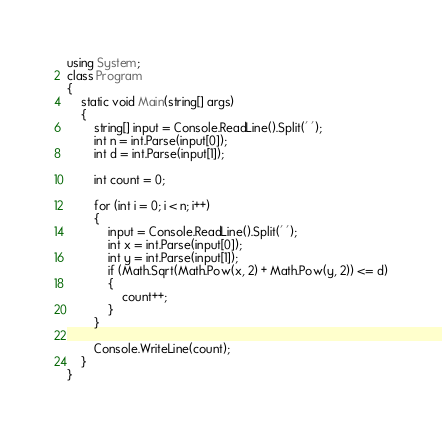Convert code to text. <code><loc_0><loc_0><loc_500><loc_500><_C#_>using System;
class Program
{
    static void Main(string[] args)
    {
        string[] input = Console.ReadLine().Split(' ');
        int n = int.Parse(input[0]);
        int d = int.Parse(input[1]);

        int count = 0;

        for (int i = 0; i < n; i++)
        {
            input = Console.ReadLine().Split(' ');
            int x = int.Parse(input[0]);
            int y = int.Parse(input[1]);
            if (Math.Sqrt(Math.Pow(x, 2) + Math.Pow(y, 2)) <= d)
            {
                count++;
            }
        }

        Console.WriteLine(count);
    }
}
</code> 